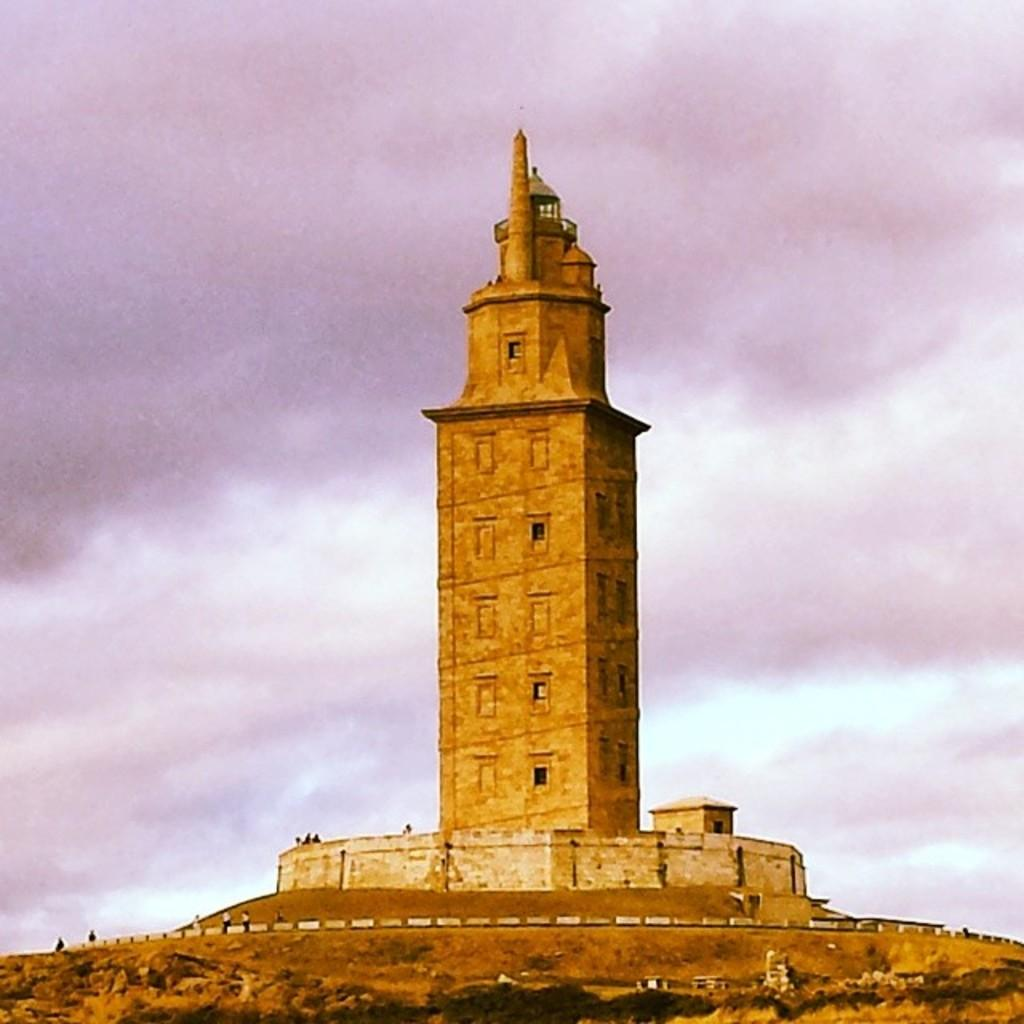What famous landmark can be seen in the image? The Tower of Hercules is present in the image. Are there any people in the image? Yes, there are people in the image. What type of terrain is visible in the image? Grass is visible on the ground in the image. What is the condition of the sky in the image? Clouds are present in the sky in the image. What angle does the story take in the image? There is no story present in the image, as it is a photograph of the Tower of Hercules and its surroundings. 